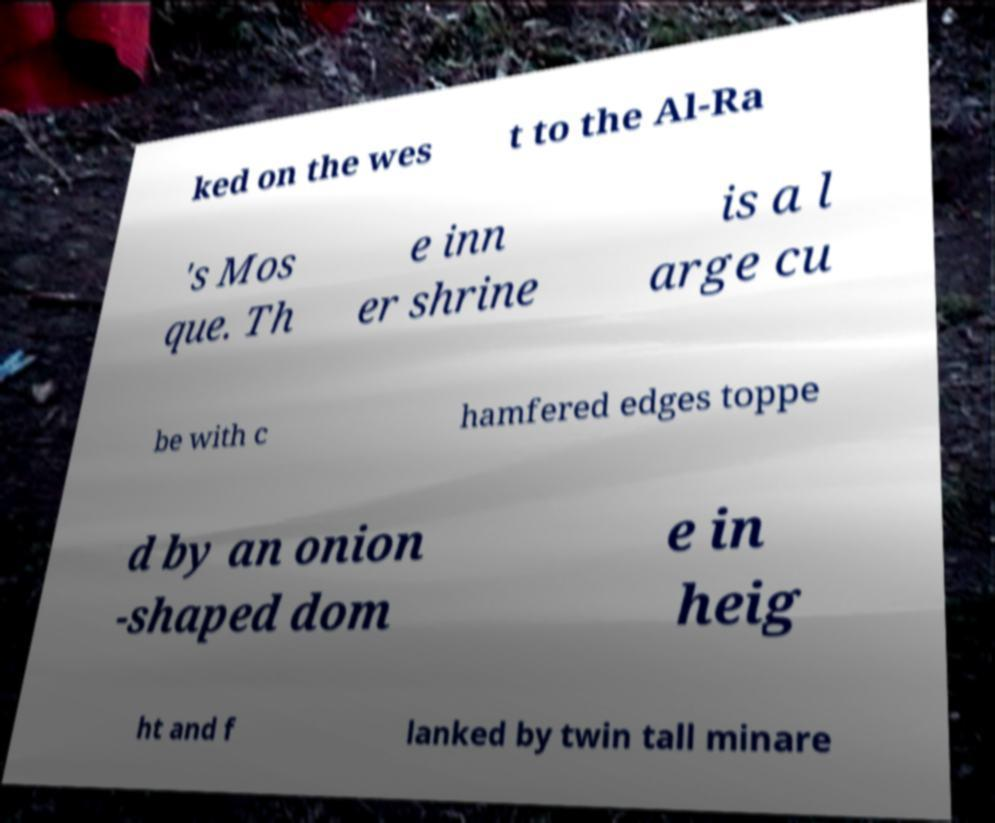Could you assist in decoding the text presented in this image and type it out clearly? ked on the wes t to the Al-Ra 's Mos que. Th e inn er shrine is a l arge cu be with c hamfered edges toppe d by an onion -shaped dom e in heig ht and f lanked by twin tall minare 